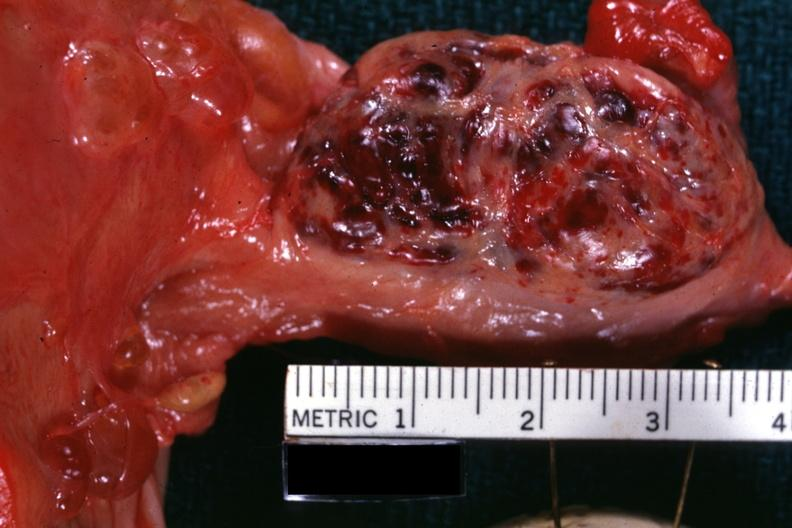s anencephaly present?
Answer the question using a single word or phrase. No 